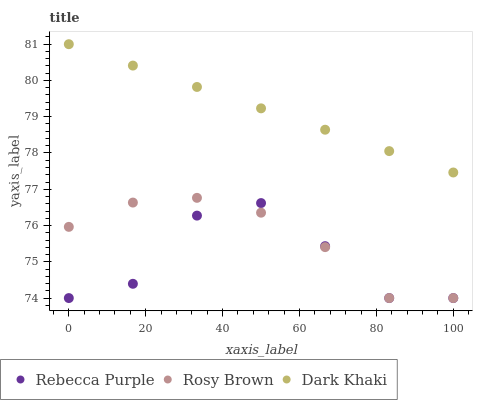Does Rebecca Purple have the minimum area under the curve?
Answer yes or no. Yes. Does Dark Khaki have the maximum area under the curve?
Answer yes or no. Yes. Does Rosy Brown have the minimum area under the curve?
Answer yes or no. No. Does Rosy Brown have the maximum area under the curve?
Answer yes or no. No. Is Dark Khaki the smoothest?
Answer yes or no. Yes. Is Rebecca Purple the roughest?
Answer yes or no. Yes. Is Rosy Brown the smoothest?
Answer yes or no. No. Is Rosy Brown the roughest?
Answer yes or no. No. Does Rosy Brown have the lowest value?
Answer yes or no. Yes. Does Dark Khaki have the highest value?
Answer yes or no. Yes. Does Rosy Brown have the highest value?
Answer yes or no. No. Is Rebecca Purple less than Dark Khaki?
Answer yes or no. Yes. Is Dark Khaki greater than Rebecca Purple?
Answer yes or no. Yes. Does Rosy Brown intersect Rebecca Purple?
Answer yes or no. Yes. Is Rosy Brown less than Rebecca Purple?
Answer yes or no. No. Is Rosy Brown greater than Rebecca Purple?
Answer yes or no. No. Does Rebecca Purple intersect Dark Khaki?
Answer yes or no. No. 